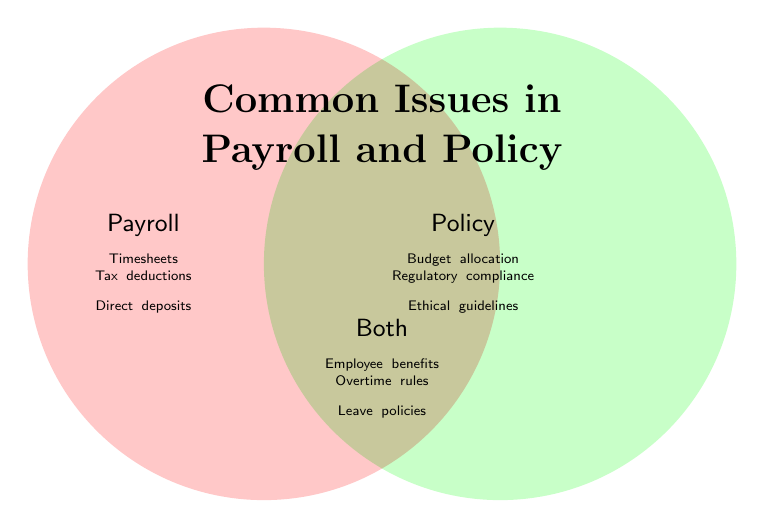What is the title of the Venn Diagram? The title is written at the top of the Venn Diagram inside the figure. It says "Common Issues in Payroll and Policy".
Answer: Common Issues in Payroll and Policy What issues are addressed by both payroll and policy? The section where the two circles overlap contains the issues addressed by both payroll and policy. The issues listed there are Employee benefits, Overtime rules, and Leave policies.
Answer: Employee benefits, Overtime rules, Leave policies How many unique issues are addressed in total by payroll and policy combined (including overlaps)? To find the total issues, count the items in the Payroll, Policy, and Both sections. There are 3 issues in Payroll, 3 in Policy, and 3 in Both. So, 3 (Payroll) + 3 (Policy) + 3 (Both) = 9 unique issues.
Answer: 9 Which section has more issues: policy or both? To compare, count the issues in both sections. Policy has 3 issues (Budget allocation, Regulatory compliance, Ethical guidelines), and Both has 3 issues (Employee benefits, Overtime rules, Leave policies). Both sections have the same number of issues.
Answer: Same number Are salary processing and legislative proposals related to policy or payroll? Look into the Payroll and Policy sections. Salary processing is in the Payroll section, and legislative proposals are in the Policy section.
Answer: Payroll (salary processing), Policy (legislative proposals) What color is used to represent the payroll section in the Venn Diagram? The payroll section is indicated by its own distinct color. It is a light shade of red.
Answer: Light red Which payroll issue can also be a policy issue as per the diagram? The overlap (Both section) covers issues common to both payroll and policy. However, it's important to note that all exclusive payroll and policy issues do not overlap.
Answer: None Explain the issues that are unique to the payroll section. The unique payroll issues are listed in the left circle. They include Timesheets, Tax deductions, Direct deposits. These are not part of the Policy section nor the Both section.
Answer: Timesheets, Tax deductions, Direct deposits 